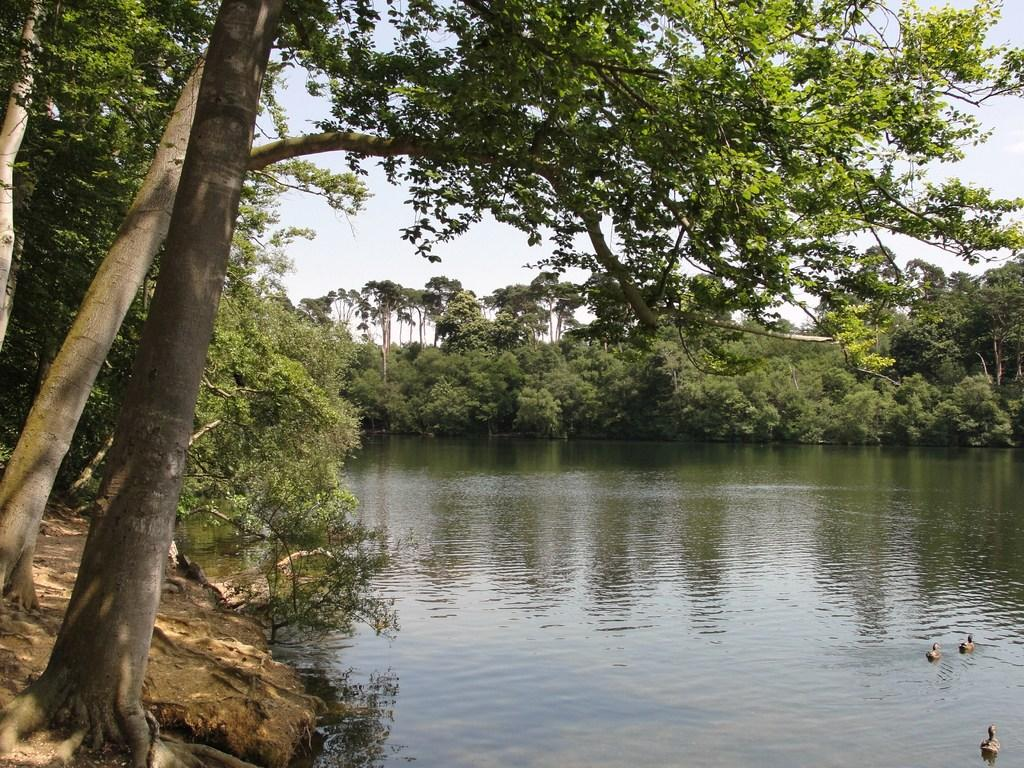What type of animals are in the water in the image? There are ducks in the water in the image. What can be seen in the background of the image? There are trees visible in the image. How would you describe the sky in the image? The sky is cloudy in the image. What type of texture can be seen on the ducks' bodies in the image? There is no specific texture mentioned or visible on the ducks' bodies in the image. What religion is practiced by the ducks in the image? There is no indication of any religious practice or belief in the image, as it features ducks in the water and trees in the background. 